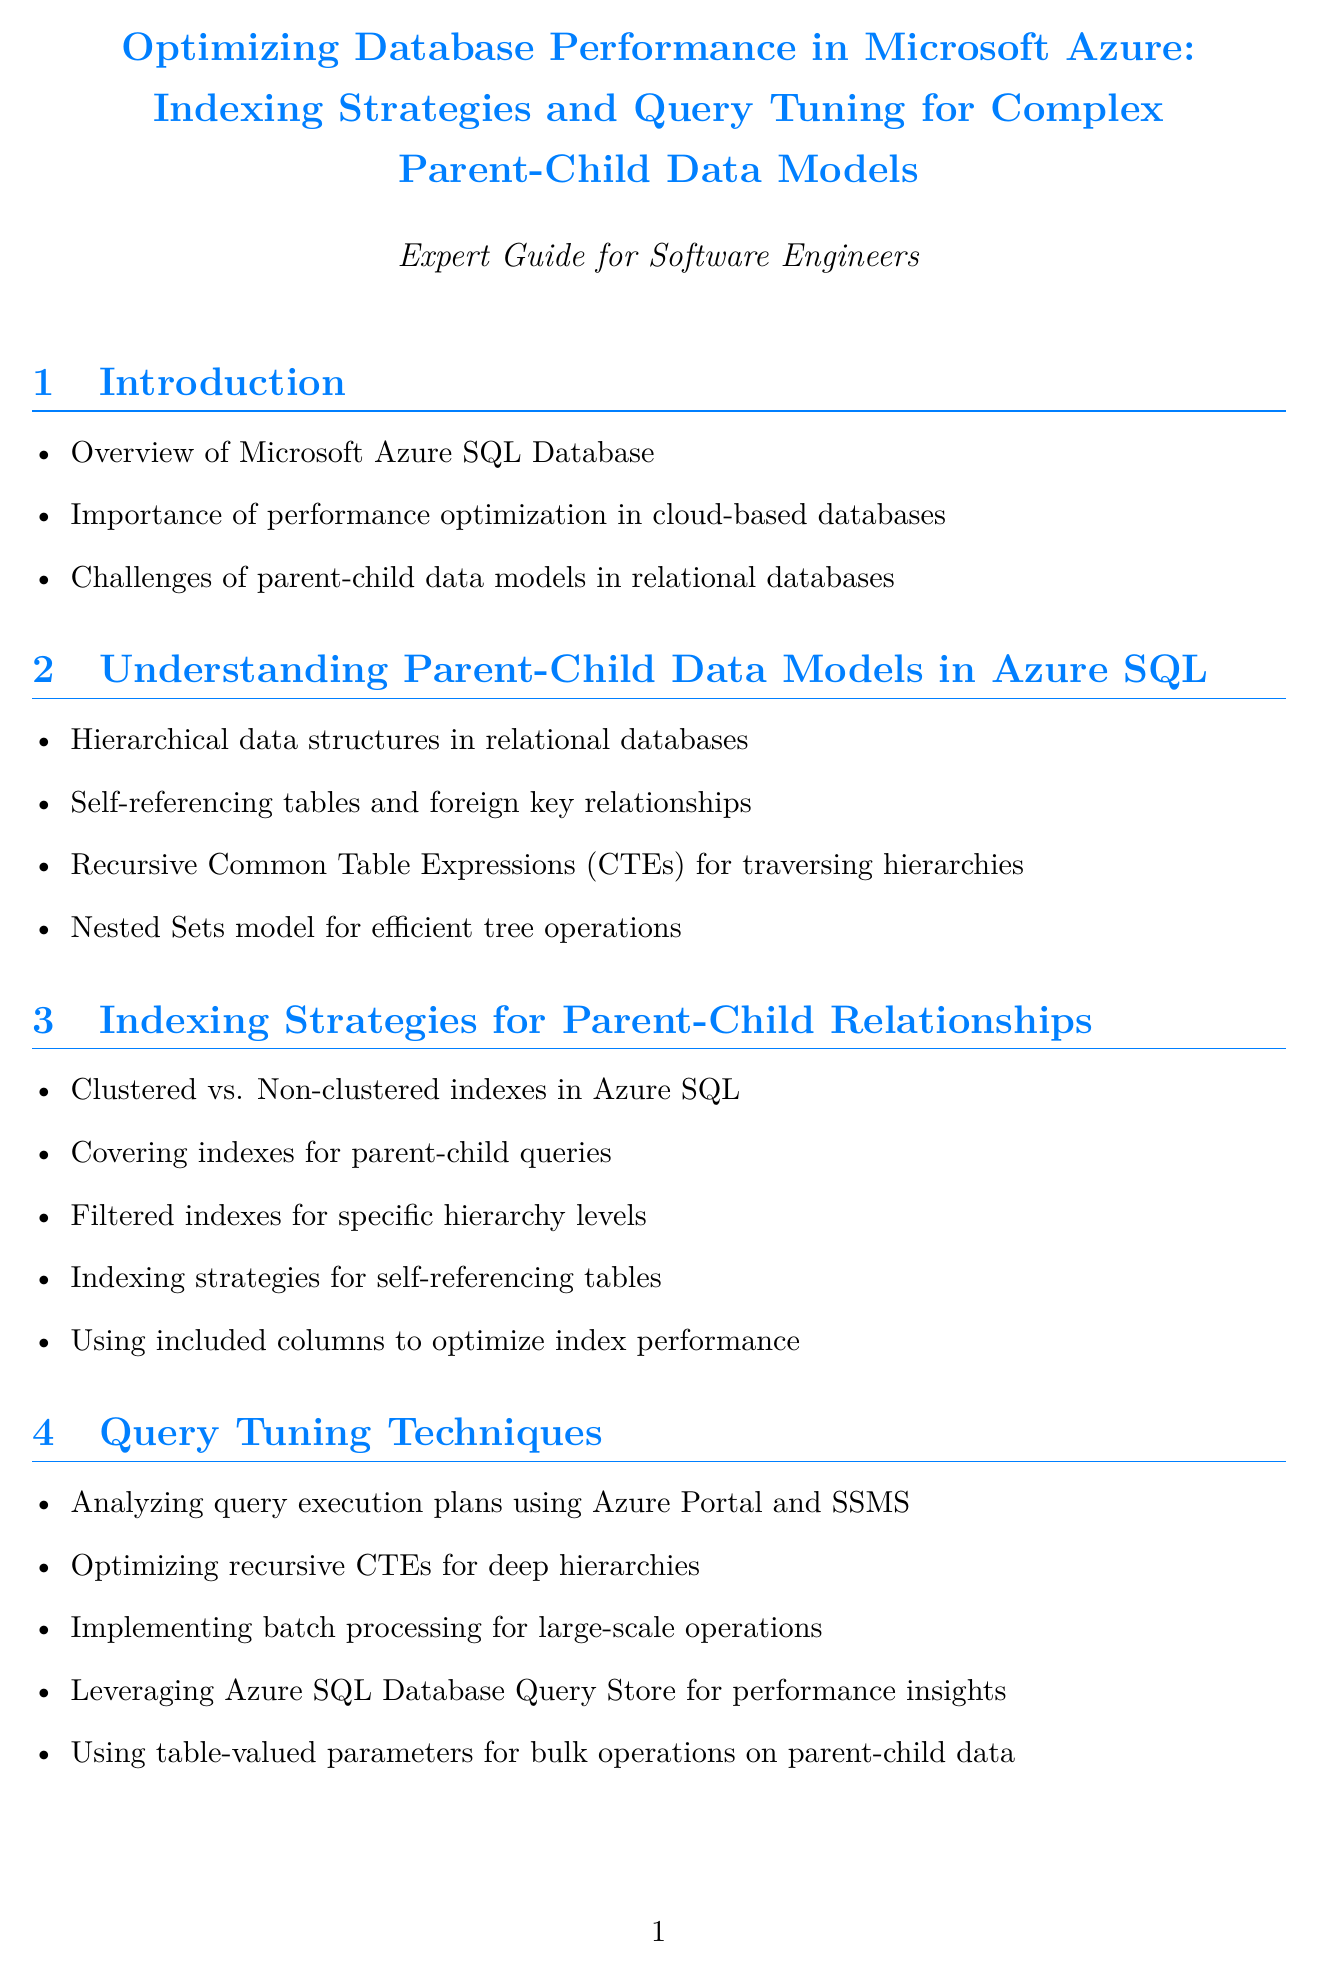What is the title of the document? The title is clearly stated at the beginning of the document, which is an important identifier for any manual.
Answer: Optimizing Database Performance in Microsoft Azure: Indexing Strategies and Query Tuning for Complex Parent-Child Data Models What is one challenge of parent-child data models? The document lists challenges specifically associated with parent-child data models, providing insights into complicated aspects of hierarchical structures.
Answer: Challenges of parent-child data models in relational databases Which company is referenced in the case study about employee hierarchy? The case studies section includes specific companies that have implemented solutions discussed in the manual.
Answer: Contoso Ltd What improvement percentage was achieved in category-based search performance? The results section of the case study provides quantifiable improvements associated with the implemented solutions.
Answer: 90% What technique is recommended for high-performance scenarios? Azure-specific optimization techniques are detailed in the document, showcasing methods for enhancing performance in cloud environments.
Answer: In-Memory OLTP What type of indexes are suggested for efficient hierarchy traversal? Indexing strategies are discussed in detail, particularly for optimizing parent-child relationships in databases.
Answer: Covering indexes for parent-child queries How often should indexes be reviewed and updated according to best practices? The best practices section includes guidance on maintaining efficient database performance through regular maintenance.
Answer: Regularly What future trend is mentioned for handling complex relationships? The future trends section outlines emerging trends that may influence database management and performance optimization moving forward.
Answer: Adopting graph database features in Azure SQL Database for complex relationships 